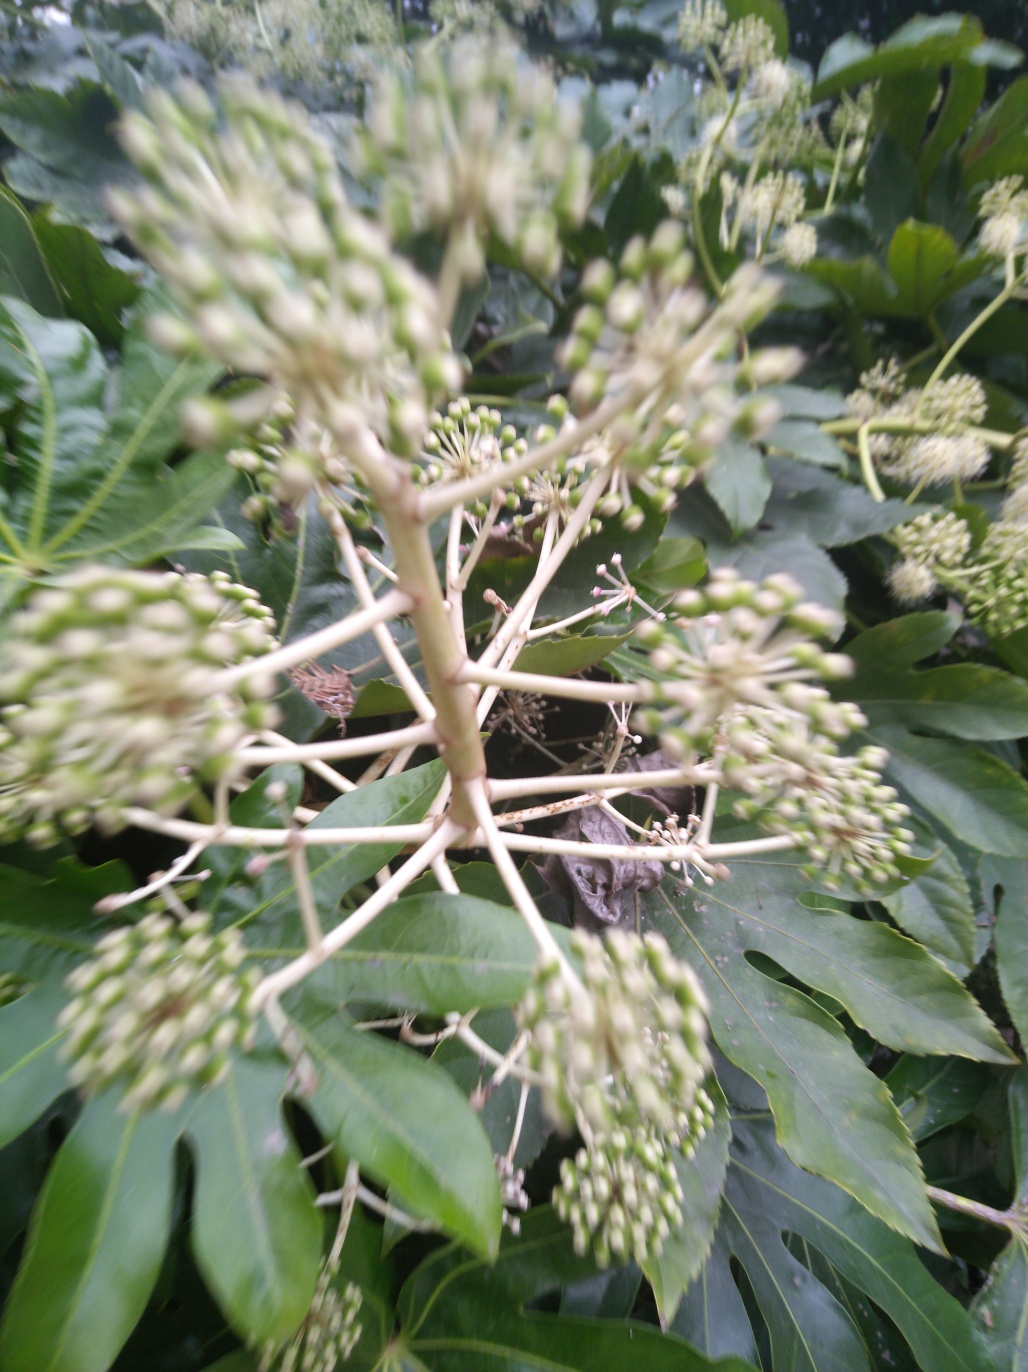What is the impact of motion blur on the image?
A. Ghosting of the main subject.
B. Sharper main subject
C. Enhanced details
Answer with the option's letter from the given choices directly.
 A. 